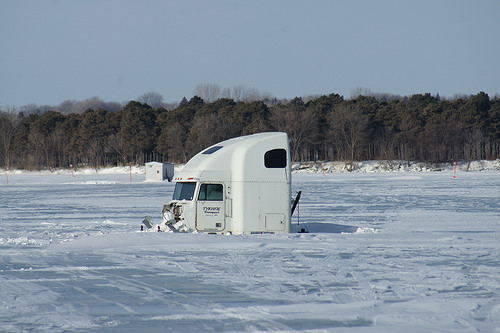<image>
Is the truck under the ice? Yes. The truck is positioned underneath the ice, with the ice above it in the vertical space. 